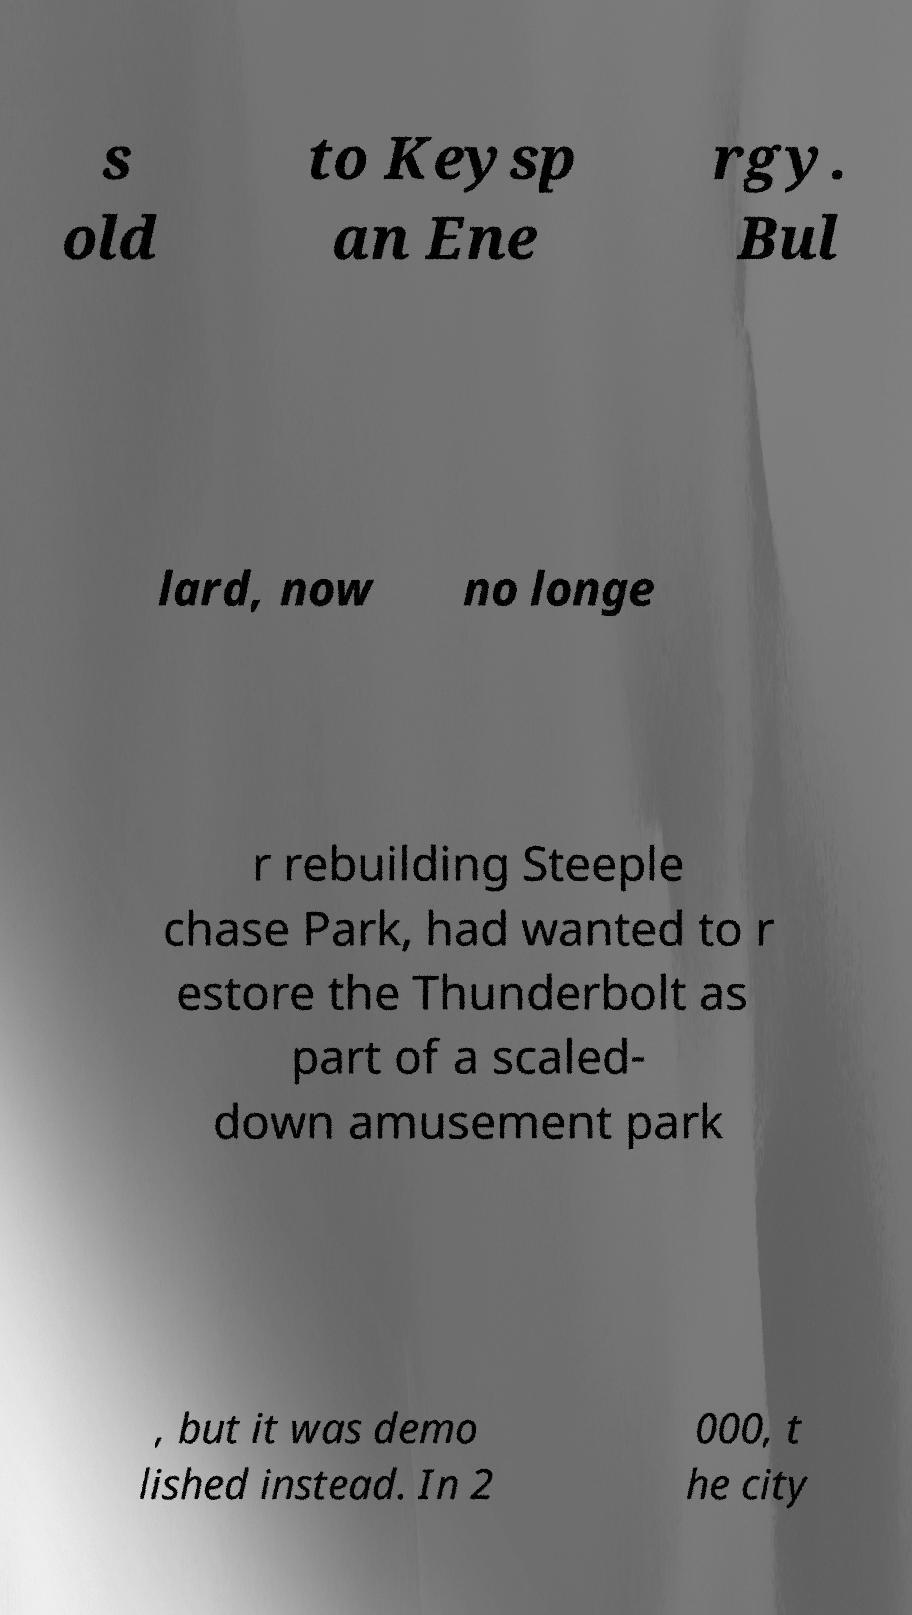Can you read and provide the text displayed in the image?This photo seems to have some interesting text. Can you extract and type it out for me? s old to Keysp an Ene rgy. Bul lard, now no longe r rebuilding Steeple chase Park, had wanted to r estore the Thunderbolt as part of a scaled- down amusement park , but it was demo lished instead. In 2 000, t he city 